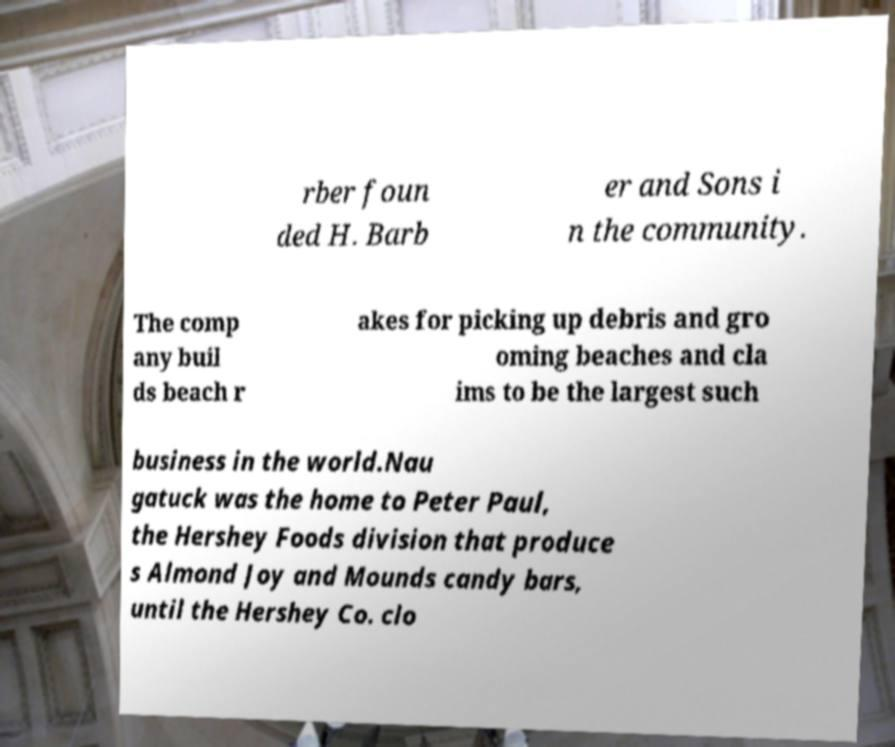Can you accurately transcribe the text from the provided image for me? rber foun ded H. Barb er and Sons i n the community. The comp any buil ds beach r akes for picking up debris and gro oming beaches and cla ims to be the largest such business in the world.Nau gatuck was the home to Peter Paul, the Hershey Foods division that produce s Almond Joy and Mounds candy bars, until the Hershey Co. clo 